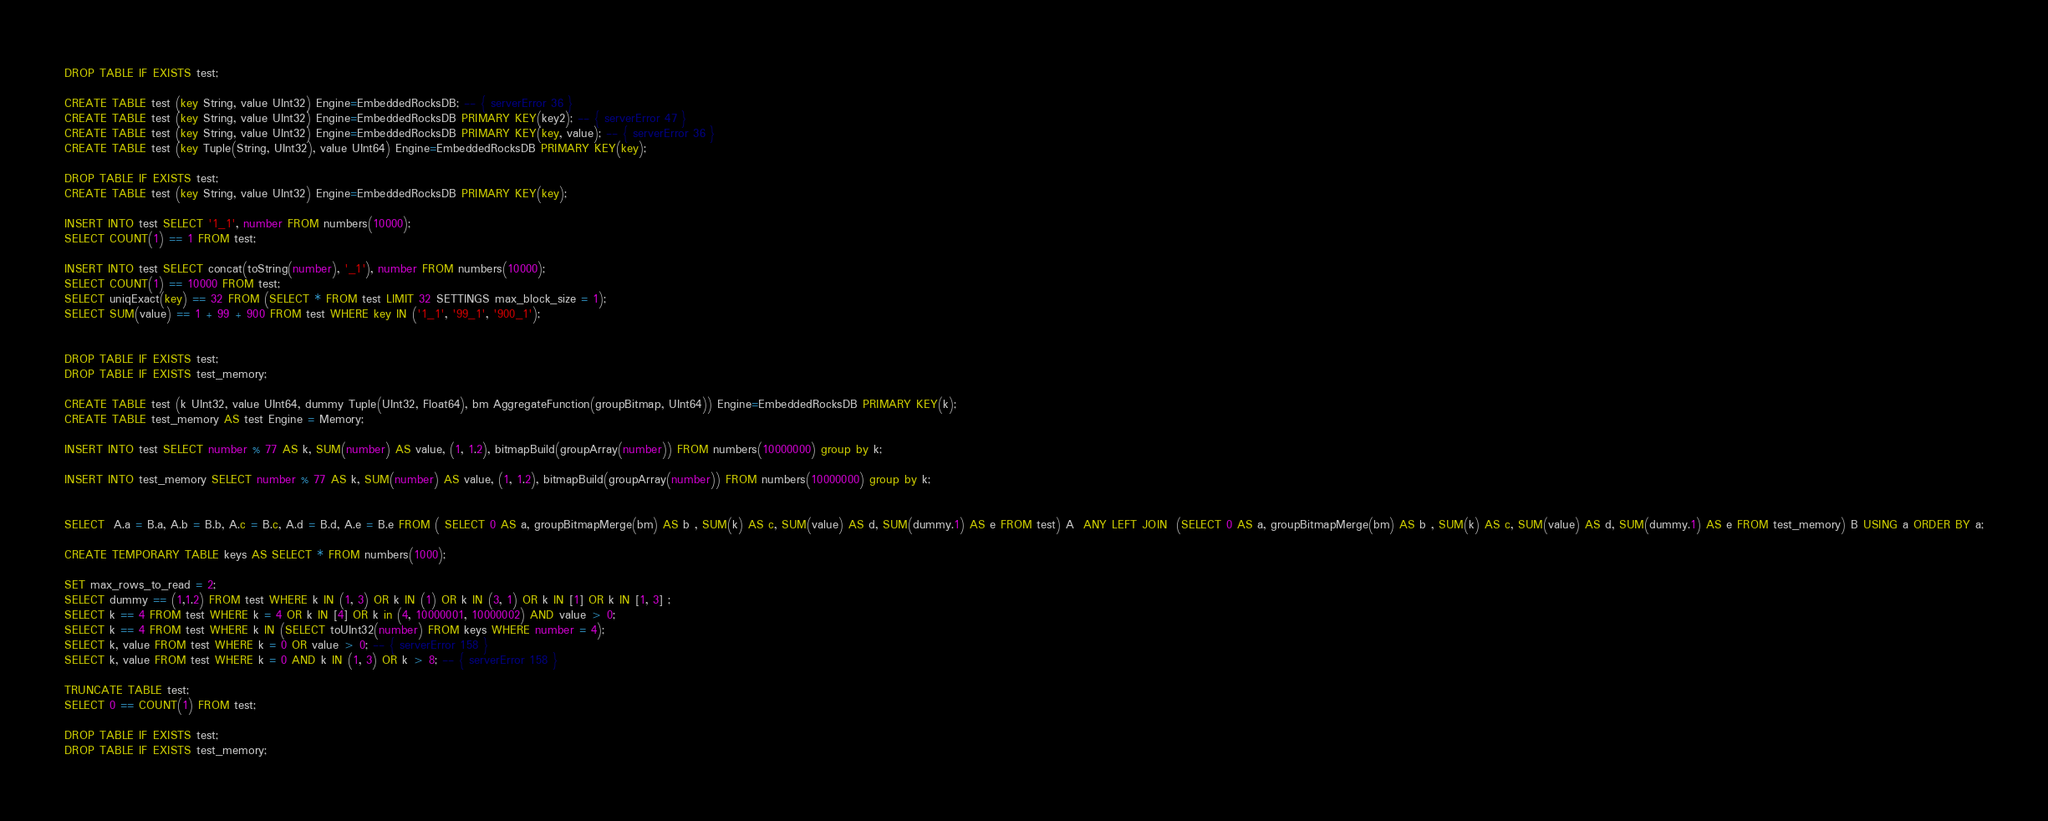<code> <loc_0><loc_0><loc_500><loc_500><_SQL_>DROP TABLE IF EXISTS test;

CREATE TABLE test (key String, value UInt32) Engine=EmbeddedRocksDB; -- { serverError 36 }
CREATE TABLE test (key String, value UInt32) Engine=EmbeddedRocksDB PRIMARY KEY(key2); -- { serverError 47 }
CREATE TABLE test (key String, value UInt32) Engine=EmbeddedRocksDB PRIMARY KEY(key, value); -- { serverError 36 }
CREATE TABLE test (key Tuple(String, UInt32), value UInt64) Engine=EmbeddedRocksDB PRIMARY KEY(key);

DROP TABLE IF EXISTS test;
CREATE TABLE test (key String, value UInt32) Engine=EmbeddedRocksDB PRIMARY KEY(key);

INSERT INTO test SELECT '1_1', number FROM numbers(10000);
SELECT COUNT(1) == 1 FROM test;

INSERT INTO test SELECT concat(toString(number), '_1'), number FROM numbers(10000);
SELECT COUNT(1) == 10000 FROM test;
SELECT uniqExact(key) == 32 FROM (SELECT * FROM test LIMIT 32 SETTINGS max_block_size = 1);
SELECT SUM(value) == 1 + 99 + 900 FROM test WHERE key IN ('1_1', '99_1', '900_1');


DROP TABLE IF EXISTS test;
DROP TABLE IF EXISTS test_memory;

CREATE TABLE test (k UInt32, value UInt64, dummy Tuple(UInt32, Float64), bm AggregateFunction(groupBitmap, UInt64)) Engine=EmbeddedRocksDB PRIMARY KEY(k);
CREATE TABLE test_memory AS test Engine = Memory;

INSERT INTO test SELECT number % 77 AS k, SUM(number) AS value, (1, 1.2), bitmapBuild(groupArray(number)) FROM numbers(10000000) group by k;

INSERT INTO test_memory SELECT number % 77 AS k, SUM(number) AS value, (1, 1.2), bitmapBuild(groupArray(number)) FROM numbers(10000000) group by k;


SELECT  A.a = B.a, A.b = B.b, A.c = B.c, A.d = B.d, A.e = B.e FROM ( SELECT 0 AS a, groupBitmapMerge(bm) AS b , SUM(k) AS c, SUM(value) AS d, SUM(dummy.1) AS e FROM test) A  ANY LEFT JOIN  (SELECT 0 AS a, groupBitmapMerge(bm) AS b , SUM(k) AS c, SUM(value) AS d, SUM(dummy.1) AS e FROM test_memory) B USING a ORDER BY a;

CREATE TEMPORARY TABLE keys AS SELECT * FROM numbers(1000);

SET max_rows_to_read = 2;
SELECT dummy == (1,1.2) FROM test WHERE k IN (1, 3) OR k IN (1) OR k IN (3, 1) OR k IN [1] OR k IN [1, 3] ;
SELECT k == 4 FROM test WHERE k = 4 OR k IN [4] OR k in (4, 10000001, 10000002) AND value > 0;
SELECT k == 4 FROM test WHERE k IN (SELECT toUInt32(number) FROM keys WHERE number = 4);
SELECT k, value FROM test WHERE k = 0 OR value > 0; -- { serverError 158 }
SELECT k, value FROM test WHERE k = 0 AND k IN (1, 3) OR k > 8; -- { serverError 158 }

TRUNCATE TABLE test;
SELECT 0 == COUNT(1) FROM test;

DROP TABLE IF EXISTS test;
DROP TABLE IF EXISTS test_memory;

</code> 